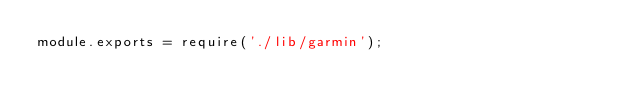<code> <loc_0><loc_0><loc_500><loc_500><_JavaScript_>module.exports = require('./lib/garmin');
</code> 